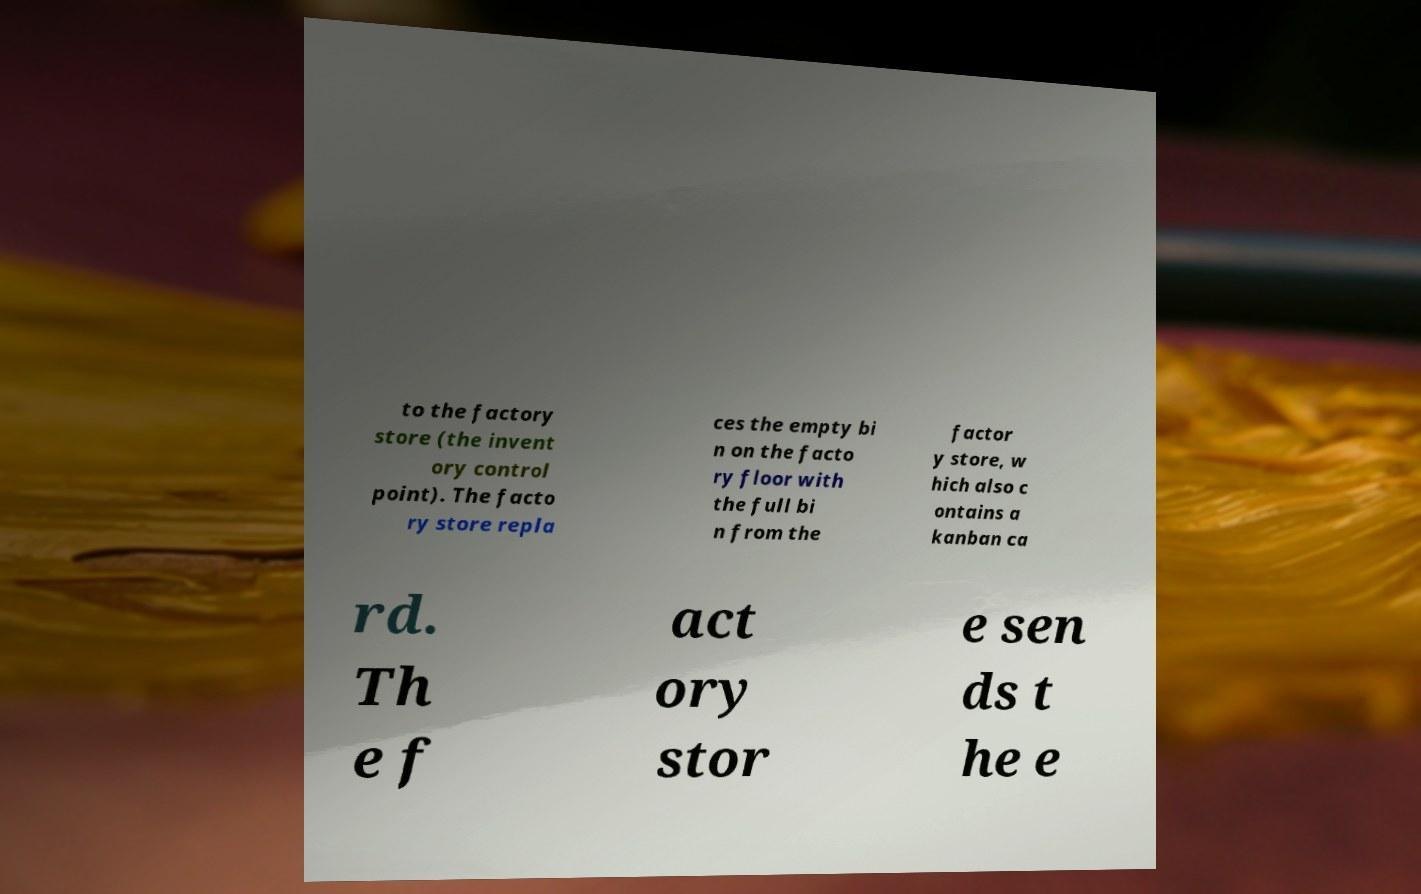Can you read and provide the text displayed in the image?This photo seems to have some interesting text. Can you extract and type it out for me? to the factory store (the invent ory control point). The facto ry store repla ces the empty bi n on the facto ry floor with the full bi n from the factor y store, w hich also c ontains a kanban ca rd. Th e f act ory stor e sen ds t he e 